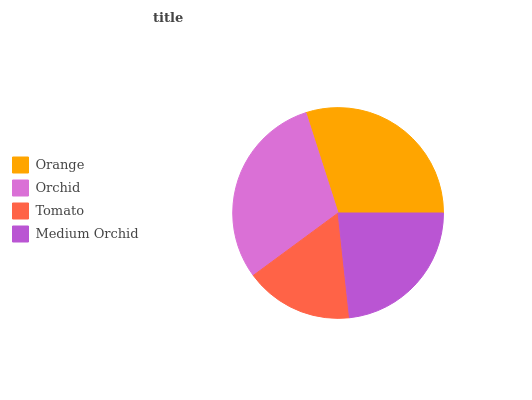Is Tomato the minimum?
Answer yes or no. Yes. Is Orchid the maximum?
Answer yes or no. Yes. Is Orchid the minimum?
Answer yes or no. No. Is Tomato the maximum?
Answer yes or no. No. Is Orchid greater than Tomato?
Answer yes or no. Yes. Is Tomato less than Orchid?
Answer yes or no. Yes. Is Tomato greater than Orchid?
Answer yes or no. No. Is Orchid less than Tomato?
Answer yes or no. No. Is Orange the high median?
Answer yes or no. Yes. Is Medium Orchid the low median?
Answer yes or no. Yes. Is Tomato the high median?
Answer yes or no. No. Is Orange the low median?
Answer yes or no. No. 